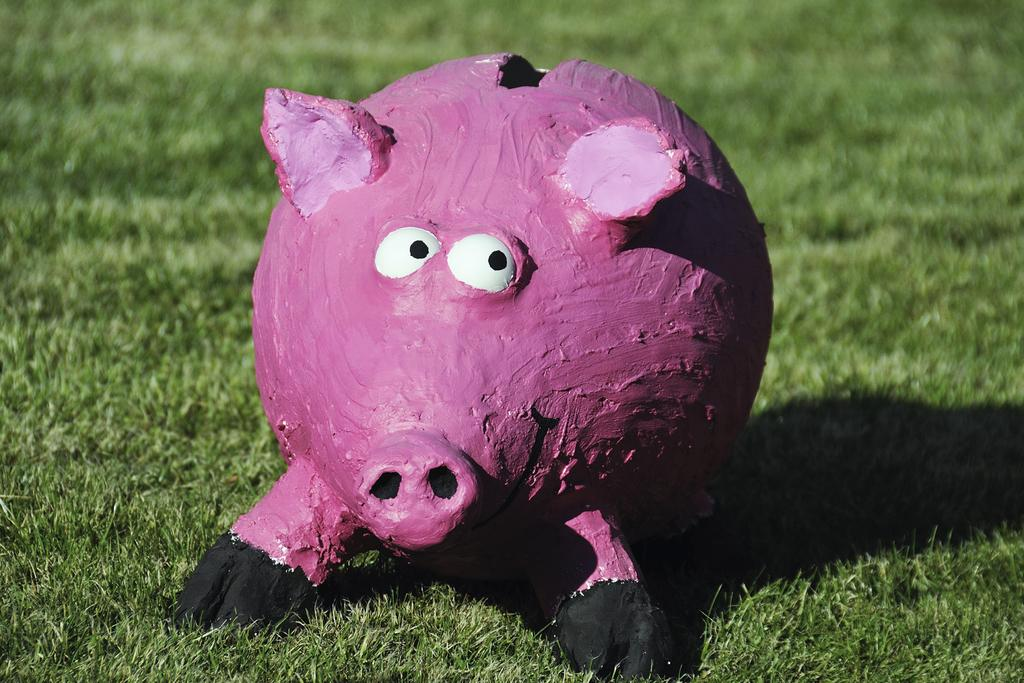What object is featured in the image? There is a pig coin bank in the image. Where is the pig coin bank located? The pig coin bank is on the grass on the ground. What type of owl can be seen sitting on the pig coin bank in the image? There is no owl present in the image; it only features a pig coin bank on the grass. What instrument is the pig coin bank playing in the image? There is no drum or any musical instrument present in the image. 